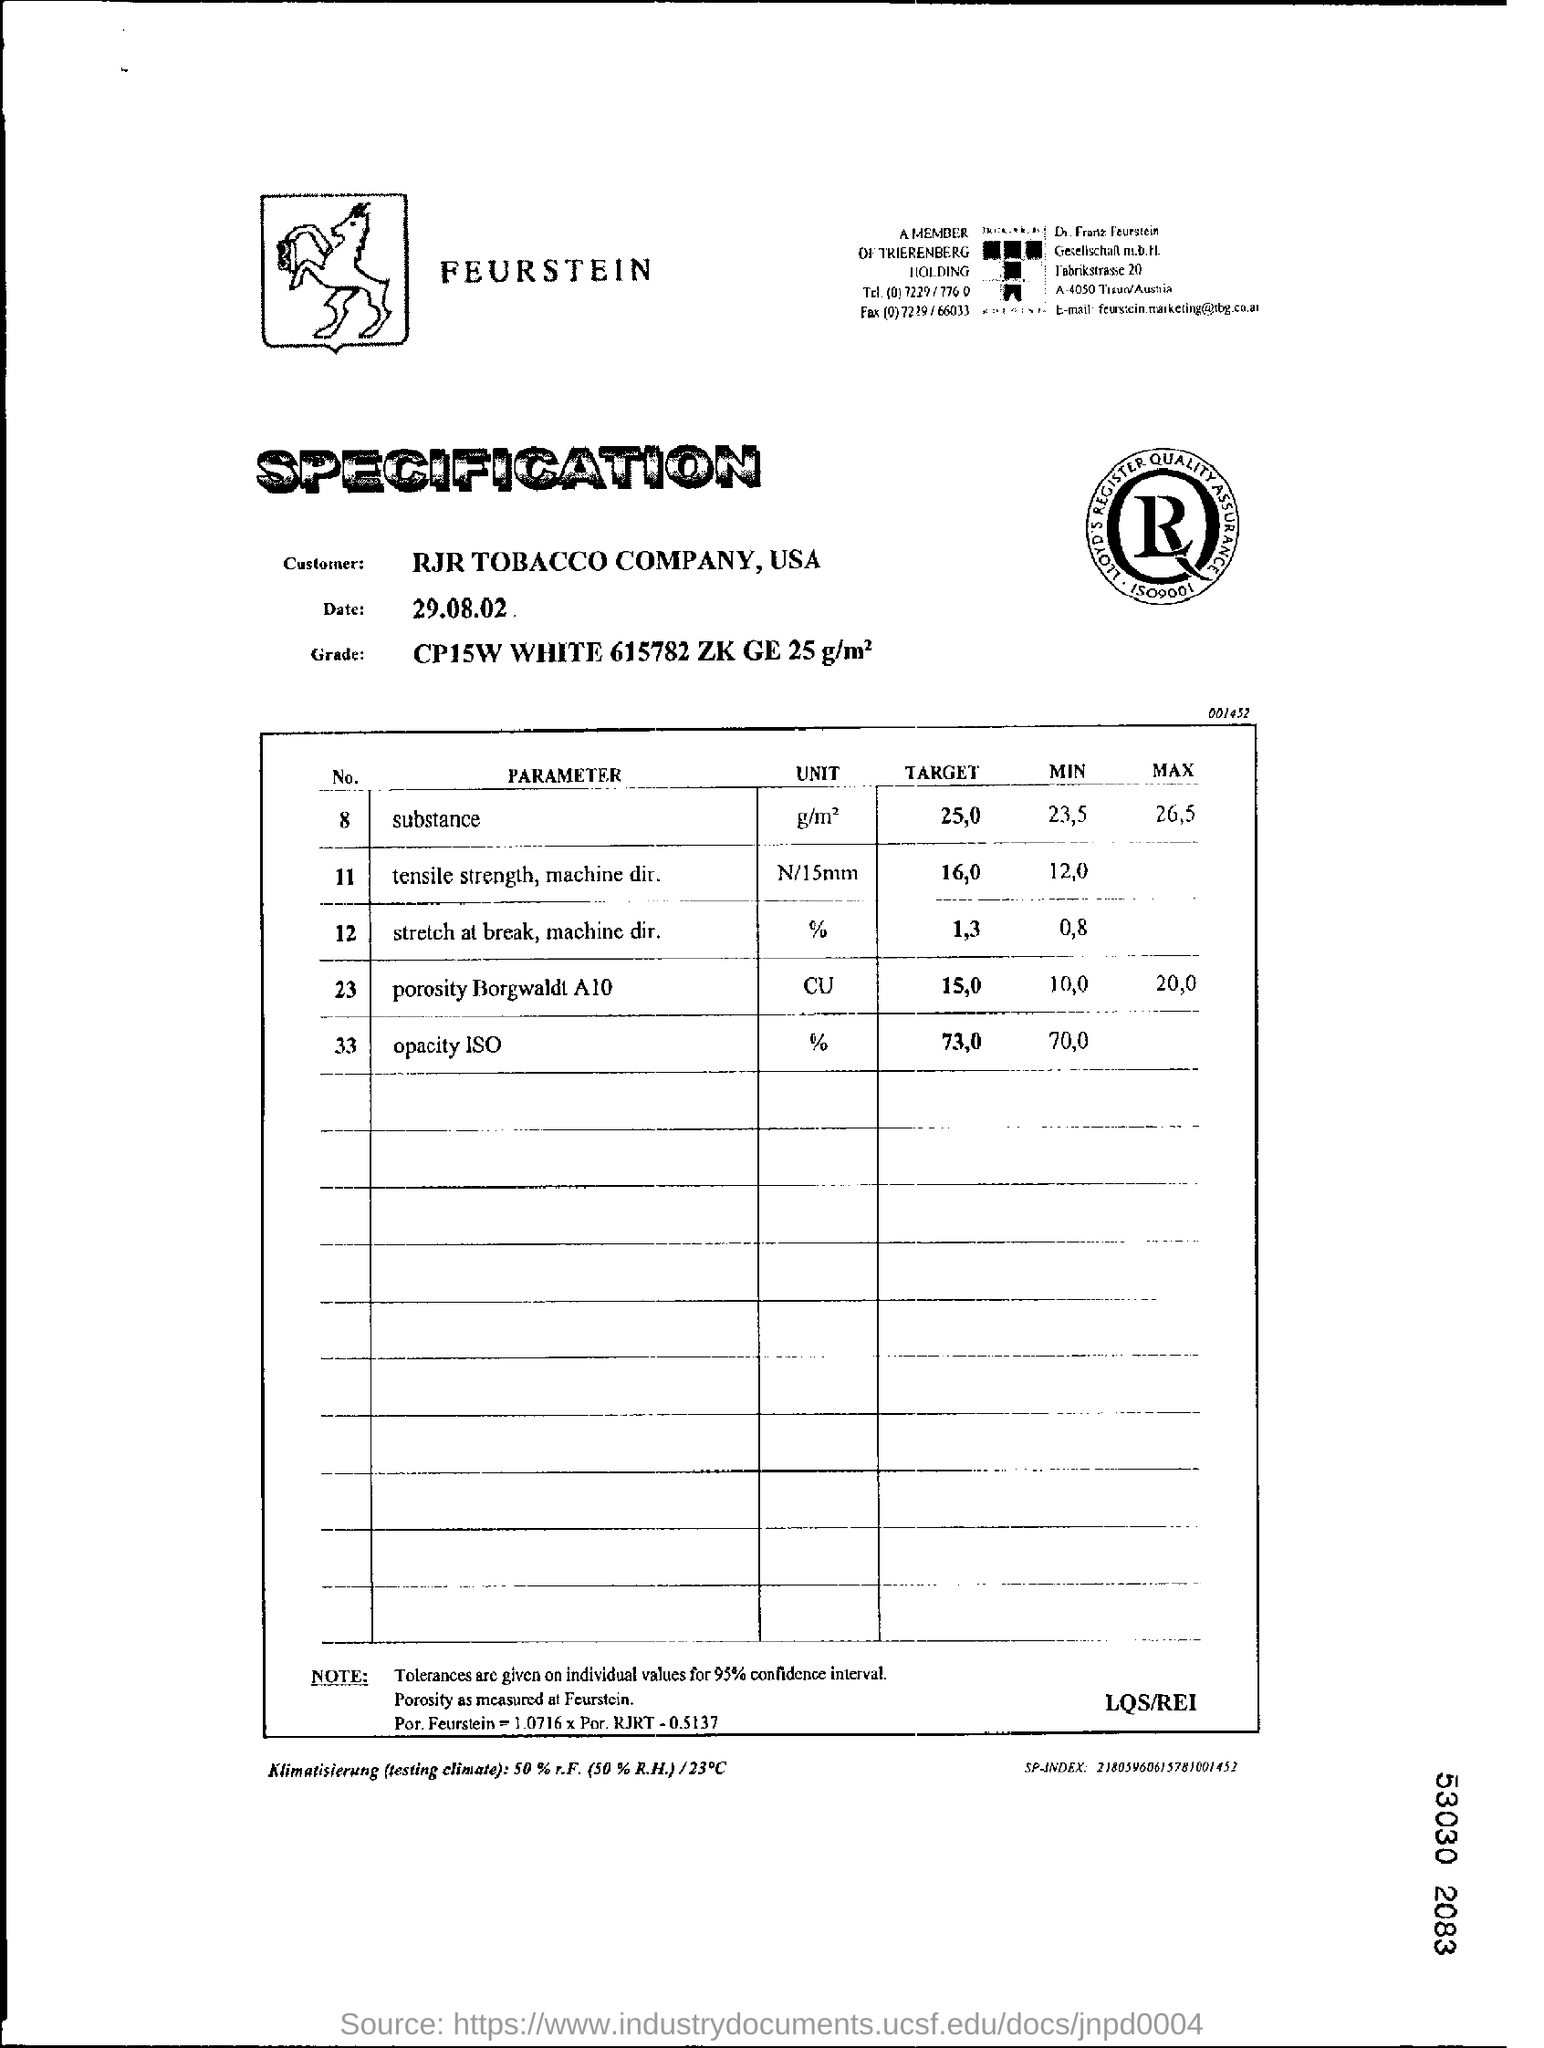What is the  TARGET of PARAMETER substance?
Offer a terse response. 25,0. What is the  MIN of PARAMETER substance?
Your answer should be very brief. 23,5. What is the  MAX of PARAMETER substance?
Ensure brevity in your answer.  26,5. What is the  TARGET of PARAMETER opacity ISO?
Ensure brevity in your answer.  73,0. What is the unit given for  PARAMETER opacity ISO?
Your answer should be very brief. %. What is the unit given for  PARAMETER Porosity Borgwaldt A10?
Give a very brief answer. CU. 